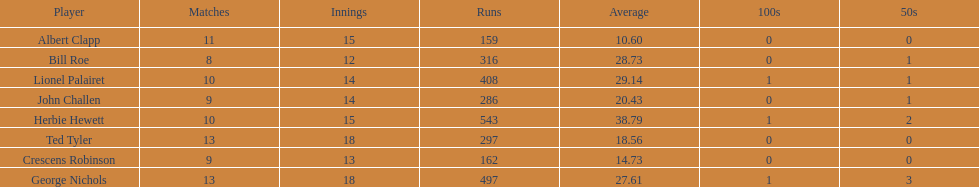How many players played more than 10 matches? 3. 